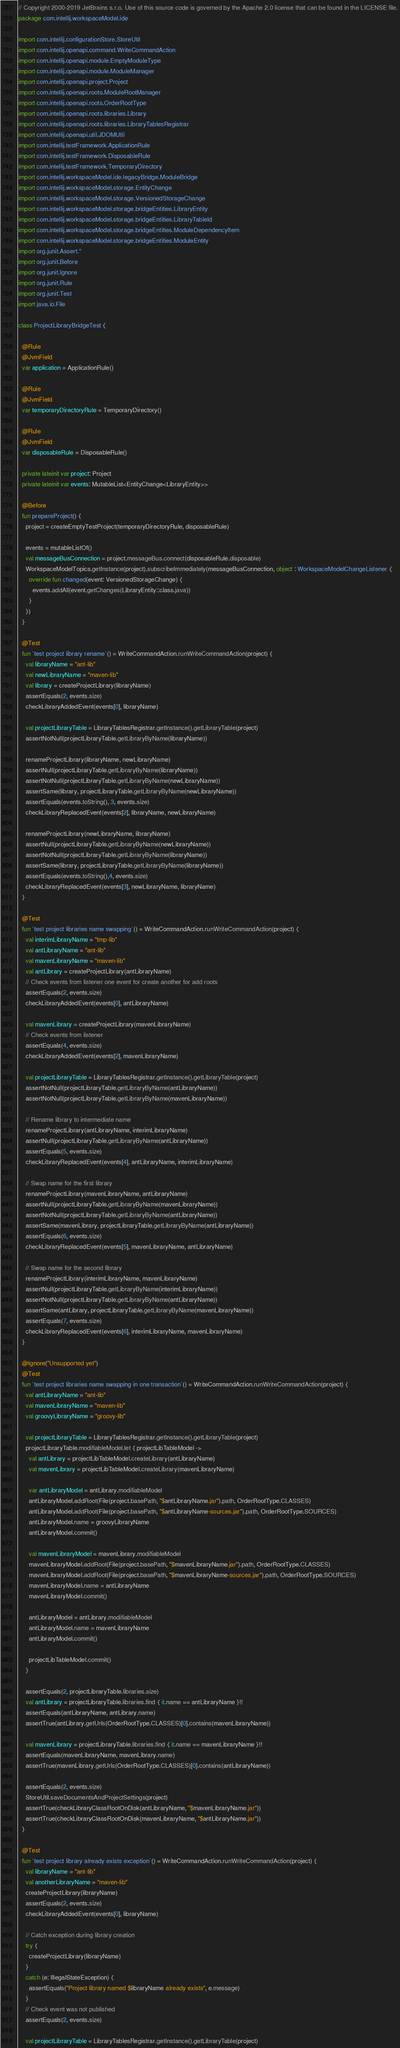<code> <loc_0><loc_0><loc_500><loc_500><_Kotlin_>// Copyright 2000-2019 JetBrains s.r.o. Use of this source code is governed by the Apache 2.0 license that can be found in the LICENSE file.
package com.intellij.workspaceModel.ide

import com.intellij.configurationStore.StoreUtil
import com.intellij.openapi.command.WriteCommandAction
import com.intellij.openapi.module.EmptyModuleType
import com.intellij.openapi.module.ModuleManager
import com.intellij.openapi.project.Project
import com.intellij.openapi.roots.ModuleRootManager
import com.intellij.openapi.roots.OrderRootType
import com.intellij.openapi.roots.libraries.Library
import com.intellij.openapi.roots.libraries.LibraryTablesRegistrar
import com.intellij.openapi.util.JDOMUtil
import com.intellij.testFramework.ApplicationRule
import com.intellij.testFramework.DisposableRule
import com.intellij.testFramework.TemporaryDirectory
import com.intellij.workspaceModel.ide.legacyBridge.ModuleBridge
import com.intellij.workspaceModel.storage.EntityChange
import com.intellij.workspaceModel.storage.VersionedStorageChange
import com.intellij.workspaceModel.storage.bridgeEntities.LibraryEntity
import com.intellij.workspaceModel.storage.bridgeEntities.LibraryTableId
import com.intellij.workspaceModel.storage.bridgeEntities.ModuleDependencyItem
import com.intellij.workspaceModel.storage.bridgeEntities.ModuleEntity
import org.junit.Assert.*
import org.junit.Before
import org.junit.Ignore
import org.junit.Rule
import org.junit.Test
import java.io.File

class ProjectLibraryBridgeTest {

  @Rule
  @JvmField
  var application = ApplicationRule()

  @Rule
  @JvmField
  var temporaryDirectoryRule = TemporaryDirectory()

  @Rule
  @JvmField
  var disposableRule = DisposableRule()

  private lateinit var project: Project
  private lateinit var events: MutableList<EntityChange<LibraryEntity>>

  @Before
  fun prepareProject() {
    project = createEmptyTestProject(temporaryDirectoryRule, disposableRule)

    events = mutableListOf()
    val messageBusConnection = project.messageBus.connect(disposableRule.disposable)
    WorkspaceModelTopics.getInstance(project).subscribeImmediately(messageBusConnection, object : WorkspaceModelChangeListener {
      override fun changed(event: VersionedStorageChange) {
        events.addAll(event.getChanges(LibraryEntity::class.java))
      }
    })
  }

  @Test
  fun `test project library rename`() = WriteCommandAction.runWriteCommandAction(project) {
    val libraryName = "ant-lib"
    val newLibraryName = "maven-lib"
    val library = createProjectLibrary(libraryName)
    assertEquals(2, events.size)
    checkLibraryAddedEvent(events[0], libraryName)

    val projectLibraryTable = LibraryTablesRegistrar.getInstance().getLibraryTable(project)
    assertNotNull(projectLibraryTable.getLibraryByName(libraryName))

    renameProjectLibrary(libraryName, newLibraryName)
    assertNull(projectLibraryTable.getLibraryByName(libraryName))
    assertNotNull(projectLibraryTable.getLibraryByName(newLibraryName))
    assertSame(library, projectLibraryTable.getLibraryByName(newLibraryName))
    assertEquals(events.toString(), 3, events.size)
    checkLibraryReplacedEvent(events[2], libraryName, newLibraryName)

    renameProjectLibrary(newLibraryName, libraryName)
    assertNull(projectLibraryTable.getLibraryByName(newLibraryName))
    assertNotNull(projectLibraryTable.getLibraryByName(libraryName))
    assertSame(library, projectLibraryTable.getLibraryByName(libraryName))
    assertEquals(events.toString(),4, events.size)
    checkLibraryReplacedEvent(events[3], newLibraryName, libraryName)
  }

  @Test
  fun `test project libraries name swapping`() = WriteCommandAction.runWriteCommandAction(project) {
    val interimLibraryName = "tmp-lib"
    val antLibraryName = "ant-lib"
    val mavenLibraryName = "maven-lib"
    val antLibrary = createProjectLibrary(antLibraryName)
    // Check events from listener one event for create another for add roots
    assertEquals(2, events.size)
    checkLibraryAddedEvent(events[0], antLibraryName)

    val mavenLibrary = createProjectLibrary(mavenLibraryName)
    // Check events from listener
    assertEquals(4, events.size)
    checkLibraryAddedEvent(events[2], mavenLibraryName)

    val projectLibraryTable = LibraryTablesRegistrar.getInstance().getLibraryTable(project)
    assertNotNull(projectLibraryTable.getLibraryByName(antLibraryName))
    assertNotNull(projectLibraryTable.getLibraryByName(mavenLibraryName))

    // Rename library to intermediate name
    renameProjectLibrary(antLibraryName, interimLibraryName)
    assertNull(projectLibraryTable.getLibraryByName(antLibraryName))
    assertEquals(5, events.size)
    checkLibraryReplacedEvent(events[4], antLibraryName, interimLibraryName)

    // Swap name for the first library
    renameProjectLibrary(mavenLibraryName, antLibraryName)
    assertNull(projectLibraryTable.getLibraryByName(mavenLibraryName))
    assertNotNull(projectLibraryTable.getLibraryByName(antLibraryName))
    assertSame(mavenLibrary, projectLibraryTable.getLibraryByName(antLibraryName))
    assertEquals(6, events.size)
    checkLibraryReplacedEvent(events[5], mavenLibraryName, antLibraryName)

    // Swap name for the second library
    renameProjectLibrary(interimLibraryName, mavenLibraryName)
    assertNull(projectLibraryTable.getLibraryByName(interimLibraryName))
    assertNotNull(projectLibraryTable.getLibraryByName(antLibraryName))
    assertSame(antLibrary, projectLibraryTable.getLibraryByName(mavenLibraryName))
    assertEquals(7, events.size)
    checkLibraryReplacedEvent(events[6], interimLibraryName, mavenLibraryName)
  }

  @Ignore("Unsupported yet")
  @Test
  fun `test project libraries name swapping in one transaction`() = WriteCommandAction.runWriteCommandAction(project) {
    val antLibraryName = "ant-lib"
    val mavenLibraryName = "maven-lib"
    val groovyLibraryName = "groovy-lib"

    val projectLibraryTable = LibraryTablesRegistrar.getInstance().getLibraryTable(project)
    projectLibraryTable.modifiableModel.let { projectLibTableModel ->
      val antLibrary = projectLibTableModel.createLibrary(antLibraryName)
      val mavenLibrary = projectLibTableModel.createLibrary(mavenLibraryName)

      var antLibraryModel = antLibrary.modifiableModel
      antLibraryModel.addRoot(File(project.basePath, "$antLibraryName.jar").path, OrderRootType.CLASSES)
      antLibraryModel.addRoot(File(project.basePath, "$antLibraryName-sources.jar").path, OrderRootType.SOURCES)
      antLibraryModel.name = groovyLibraryName
      antLibraryModel.commit()

      val mavenLibraryModel = mavenLibrary.modifiableModel
      mavenLibraryModel.addRoot(File(project.basePath, "$mavenLibraryName.jar").path, OrderRootType.CLASSES)
      mavenLibraryModel.addRoot(File(project.basePath, "$mavenLibraryName-sources.jar").path, OrderRootType.SOURCES)
      mavenLibraryModel.name = antLibraryName
      mavenLibraryModel.commit()

      antLibraryModel = antLibrary.modifiableModel
      antLibraryModel.name = mavenLibraryName
      antLibraryModel.commit()

      projectLibTableModel.commit()
    }

    assertEquals(2, projectLibraryTable.libraries.size)
    val antLibrary = projectLibraryTable.libraries.find { it.name == antLibraryName }!!
    assertEquals(antLibraryName, antLibrary.name)
    assertTrue(antLibrary.getUrls(OrderRootType.CLASSES)[0].contains(mavenLibraryName))

    val mavenLibrary = projectLibraryTable.libraries.find { it.name == mavenLibraryName }!!
    assertEquals(mavenLibraryName, mavenLibrary.name)
    assertTrue(mavenLibrary.getUrls(OrderRootType.CLASSES)[0].contains(antLibraryName))

    assertEquals(2, events.size)
    StoreUtil.saveDocumentsAndProjectSettings(project)
    assertTrue(checkLibraryClassRootOnDisk(antLibraryName, "$mavenLibraryName.jar"))
    assertTrue(checkLibraryClassRootOnDisk(mavenLibraryName, "$antLibraryName.jar"))
  }

  @Test
  fun `test project library already exists exception`() = WriteCommandAction.runWriteCommandAction(project) {
    val libraryName = "ant-lib"
    val anotherLibraryName = "maven-lib"
    createProjectLibrary(libraryName)
    assertEquals(2, events.size)
    checkLibraryAddedEvent(events[0], libraryName)

    // Catch exception during library creation
    try {
      createProjectLibrary(libraryName)
    }
    catch (e: IllegalStateException) {
      assertEquals("Project library named $libraryName already exists", e.message)
    }
    // Check event was not published
    assertEquals(2, events.size)

    val projectLibraryTable = LibraryTablesRegistrar.getInstance().getLibraryTable(project)</code> 